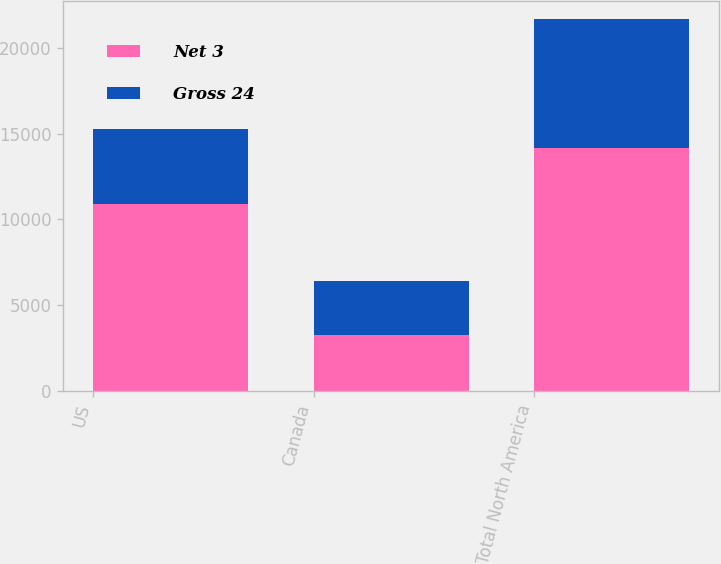<chart> <loc_0><loc_0><loc_500><loc_500><stacked_bar_chart><ecel><fcel>US<fcel>Canada<fcel>Total North America<nl><fcel>Net 3<fcel>10895<fcel>3264<fcel>14159<nl><fcel>Gross 24<fcel>4352<fcel>3166<fcel>7518<nl></chart> 